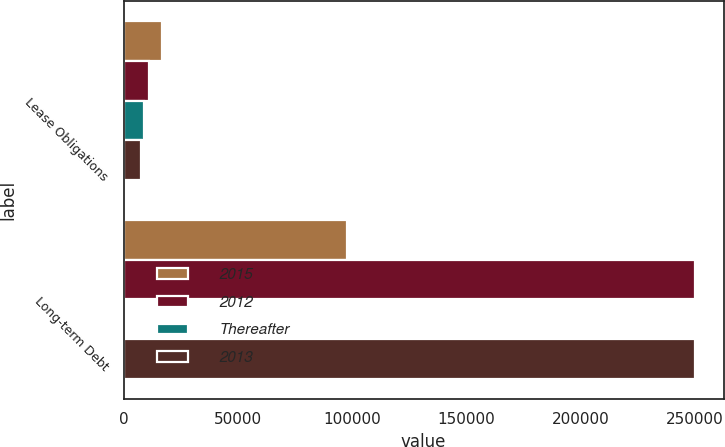Convert chart. <chart><loc_0><loc_0><loc_500><loc_500><stacked_bar_chart><ecel><fcel>Lease Obligations<fcel>Long-term Debt<nl><fcel>2015<fcel>16851<fcel>97593<nl><fcel>2012<fcel>11108<fcel>250187<nl><fcel>Thereafter<fcel>8846<fcel>187<nl><fcel>2013<fcel>7692<fcel>250187<nl></chart> 